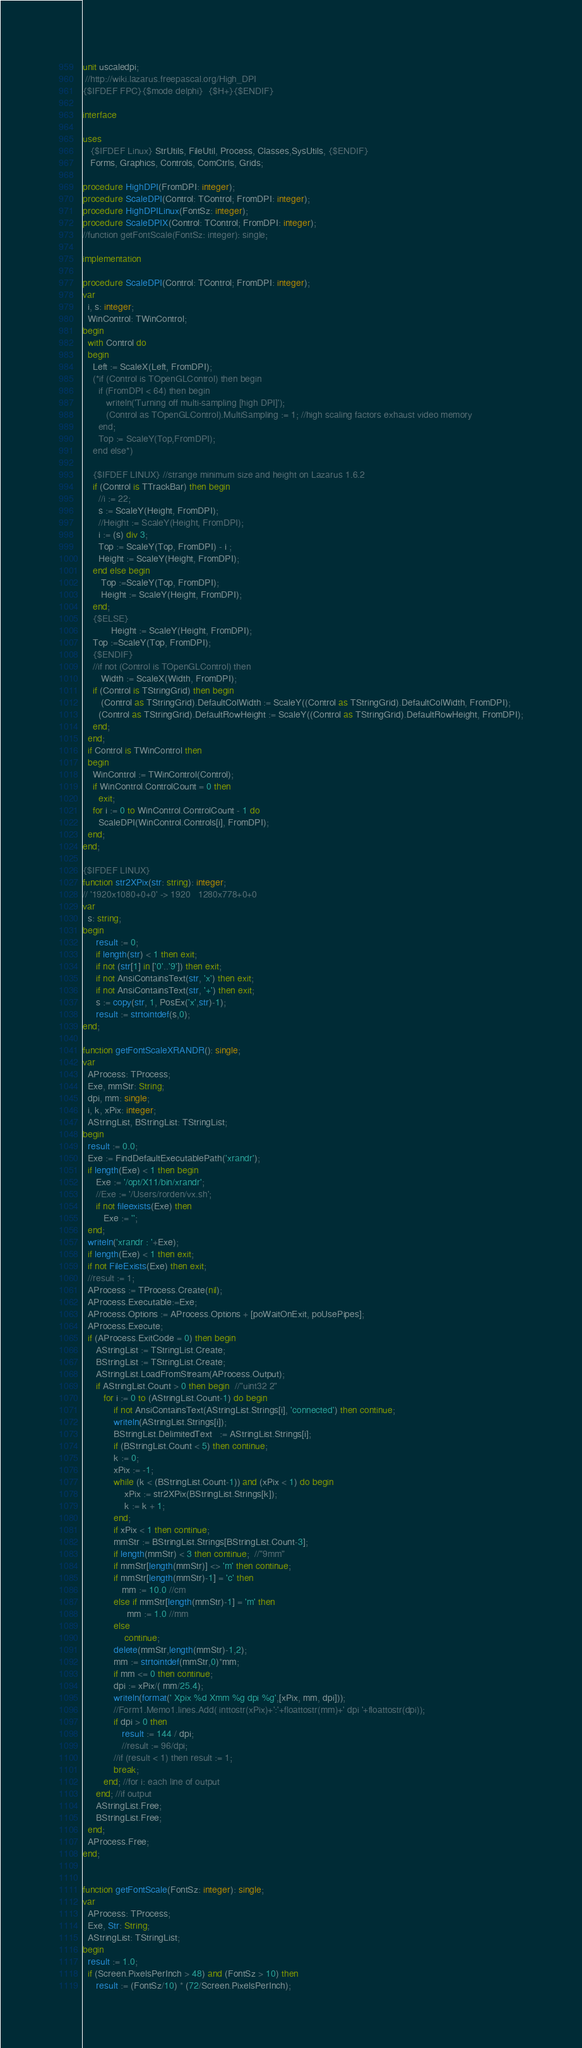Convert code to text. <code><loc_0><loc_0><loc_500><loc_500><_Pascal_>unit uscaledpi;
 //http://wiki.lazarus.freepascal.org/High_DPI
{$IFDEF FPC}{$mode delphi}  {$H+}{$ENDIF}

interface

uses
   {$IFDEF Linux} StrUtils, FileUtil, Process, Classes,SysUtils, {$ENDIF}
   Forms, Graphics, Controls, ComCtrls, Grids;

procedure HighDPI(FromDPI: integer);
procedure ScaleDPI(Control: TControl; FromDPI: integer);
procedure HighDPILinux(FontSz: integer);
procedure ScaleDPIX(Control: TControl; FromDPI: integer);
//function getFontScale(FontSz: integer): single;

implementation

procedure ScaleDPI(Control: TControl; FromDPI: integer);
var
  i, s: integer;
  WinControl: TWinControl;
begin
  with Control do
  begin
    Left := ScaleX(Left, FromDPI);
    (*if (Control is TOpenGLControl) then begin
      if (FromDPI < 64) then begin
         writeln('Turning off multi-sampling [high DPI]');
         (Control as TOpenGLControl).MultiSampling := 1; //high scaling factors exhaust video memory
      end;
      Top := ScaleY(Top,FromDPI);
    end else*)

    {$IFDEF LINUX} //strange minimum size and height on Lazarus 1.6.2
    if (Control is TTrackBar) then begin
      //i := 22;
      s := ScaleY(Height, FromDPI);
      //Height := ScaleY(Height, FromDPI);
      i := (s) div 3;
      Top := ScaleY(Top, FromDPI) - i ;
      Height := ScaleY(Height, FromDPI);
    end else begin
       Top :=ScaleY(Top, FromDPI);
       Height := ScaleY(Height, FromDPI);
    end;
    {$ELSE}
           Height := ScaleY(Height, FromDPI);
    Top :=ScaleY(Top, FromDPI);
    {$ENDIF}
    //if not (Control is TOpenGLControl) then
       Width := ScaleX(Width, FromDPI);
    if (Control is TStringGrid) then begin
       (Control as TStringGrid).DefaultColWidth := ScaleY((Control as TStringGrid).DefaultColWidth, FromDPI);
      (Control as TStringGrid).DefaultRowHeight := ScaleY((Control as TStringGrid).DefaultRowHeight, FromDPI);
    end;
  end;
  if Control is TWinControl then
  begin
    WinControl := TWinControl(Control);
    if WinControl.ControlCount = 0 then
      exit;
    for i := 0 to WinControl.ControlCount - 1 do
      ScaleDPI(WinControl.Controls[i], FromDPI);
  end;
end;

{$IFDEF LINUX}
function str2XPix(str: string): integer;
// '1920x1080+0+0' -> 1920   1280x778+0+0
var
  s: string;
begin
     result := 0;
     if length(str) < 1 then exit;
     if not (str[1] in ['0'..'9']) then exit;
     if not AnsiContainsText(str, 'x') then exit;
     if not AnsiContainsText(str, '+') then exit;
     s := copy(str, 1, PosEx('x',str)-1);
     result := strtointdef(s,0);
end;

function getFontScaleXRANDR(): single;
var
  AProcess: TProcess;
  Exe, mmStr: String;
  dpi, mm: single;
  i, k, xPix: integer;
  AStringList, BStringList: TStringList;
begin
  result := 0.0;
  Exe := FindDefaultExecutablePath('xrandr');
  if length(Exe) < 1 then begin
     Exe := '/opt/X11/bin/xrandr';
     //Exe := '/Users/rorden/vx.sh';
     if not fileexists(Exe) then
        Exe := '';
  end;
  writeln('xrandr : '+Exe);
  if length(Exe) < 1 then exit;
  if not FileExists(Exe) then exit;
  //result := 1;
  AProcess := TProcess.Create(nil);
  AProcess.Executable:=Exe;
  AProcess.Options := AProcess.Options + [poWaitOnExit, poUsePipes];
  AProcess.Execute;
  if (AProcess.ExitCode = 0) then begin
     AStringList := TStringList.Create;
     BStringList := TStringList.Create;
     AStringList.LoadFromStream(AProcess.Output);
     if AStringList.Count > 0 then begin  //"uint32 2"
        for i := 0 to (AStringList.Count-1) do begin
            if not AnsiContainsText(AStringList.Strings[i], 'connected') then continue;
            writeln(AStringList.Strings[i]);
            BStringList.DelimitedText   := AStringList.Strings[i];
            if (BStringList.Count < 5) then continue;
            k := 0;
            xPix := -1;
            while (k < (BStringList.Count-1)) and (xPix < 1) do begin
                xPix := str2XPix(BStringList.Strings[k]);
                k := k + 1;
            end;
            if xPix < 1 then continue;
            mmStr := BStringList.Strings[BStringList.Count-3];
            if length(mmStr) < 3 then continue;  //"9mm"
            if mmStr[length(mmStr)] <> 'm' then continue;
            if mmStr[length(mmStr)-1] = 'c' then
               mm := 10.0 //cm
            else if mmStr[length(mmStr)-1] = 'm' then
                 mm := 1.0 //mm
            else
                continue;
            delete(mmStr,length(mmStr)-1,2);
            mm := strtointdef(mmStr,0)*mm;
            if mm <= 0 then continue;
            dpi := xPix/( mm/25.4);
            writeln(format(' Xpix %d Xmm %g dpi %g',[xPix, mm, dpi]));
            //Form1.Memo1.lines.Add( inttostr(xPix)+':'+floattostr(mm)+' dpi '+floattostr(dpi));
            if dpi > 0 then
               result := 144 / dpi;
               //result := 96/dpi;
            //if (result < 1) then result := 1;
            break;
        end; //for i: each line of output
     end; //if output
     AStringList.Free;
     BStringList.Free;
  end;
  AProcess.Free;
end;


function getFontScale(FontSz: integer): single;
var
  AProcess: TProcess;
  Exe, Str: String;
  AStringList: TStringList;
begin
  result := 1.0;
  if (Screen.PixelsPerInch > 48) and (FontSz > 10) then
     result := (FontSz/10) * (72/Screen.PixelsPerInch);</code> 